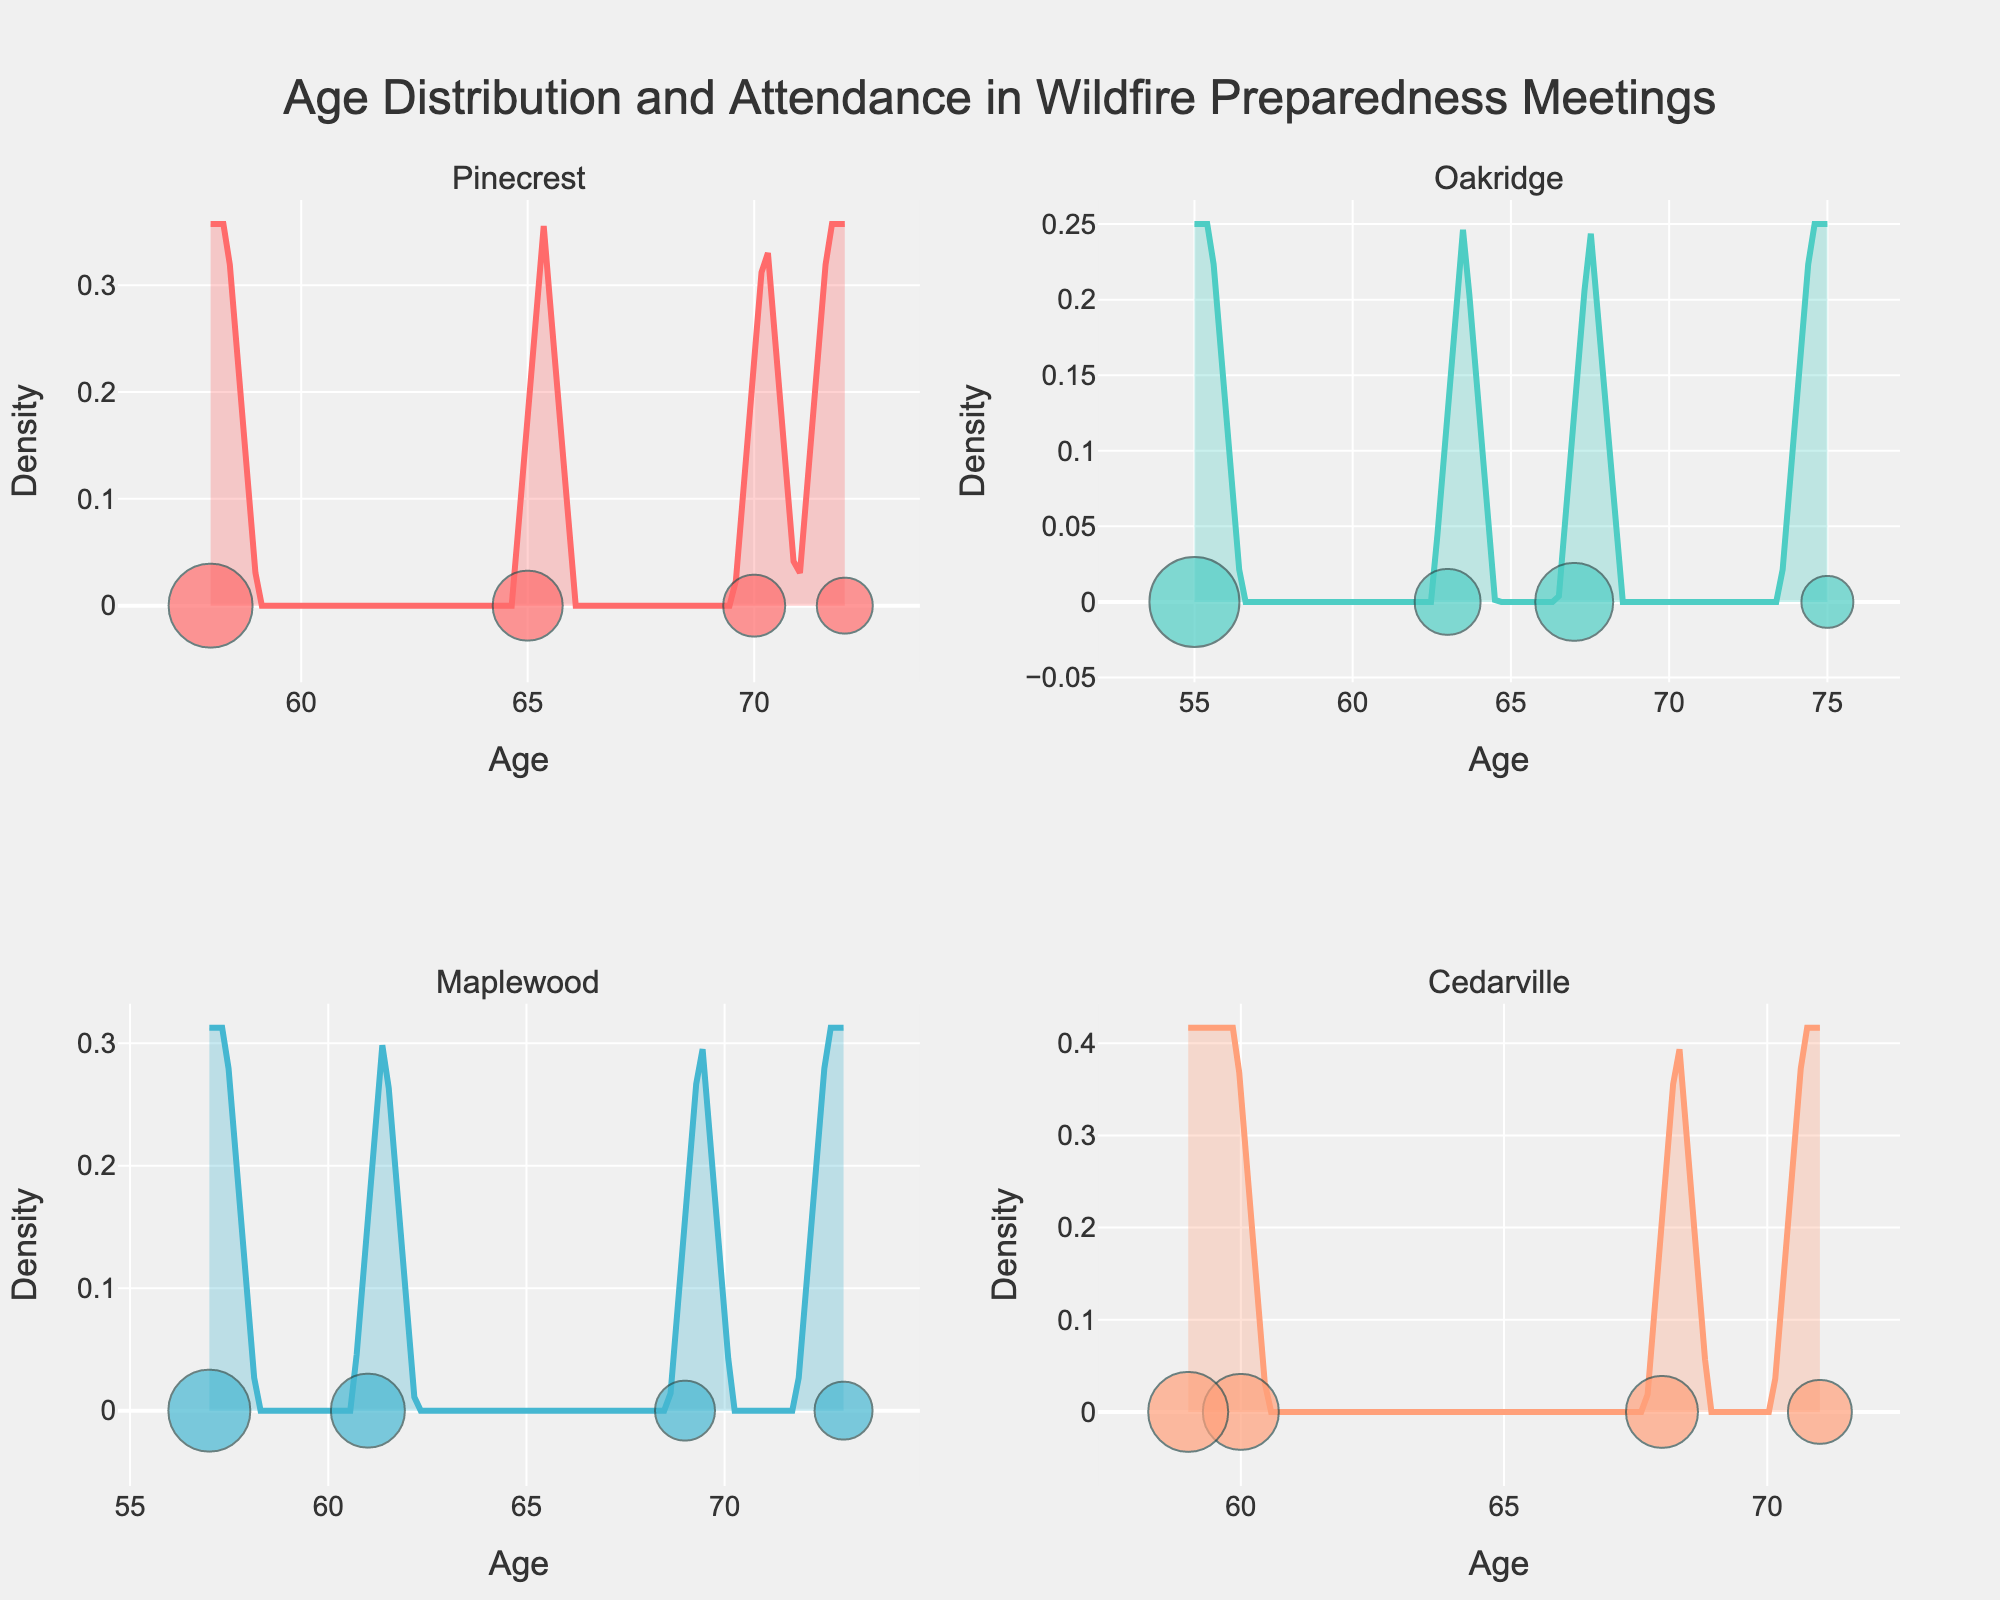Which community subplot has the highest peak density? In the figure, observe the height of peak densities in each community's subplot. The community with the tallest peak indicates the highest density.
Answer: Oakridge Which community shows the most dispersed age distribution? The community with the widest spread of the density curve indicates more dispersion. Check the subplots to see which community's density curve spans the largest range of ages.
Answer: Cedarville What is the title of the figure? The title is located at the top of the figure.
Answer: Age Distribution and Attendance in Wildfire Preparedness Meetings Are there any outliers in the Pinecrest attendance markers? Look at the Pinecrest subplot and identify any points that are significantly separate from others in terms of size or position.
Answer: No Which community has the smallest age range? Identify the span of ages in each subplot and note which has the smallest difference between the highest and lowest ages.
Answer: Cedarville Which community's subplot contains the markers with the largest attendance size? Examine all subplots and compare the relative sizes of the markers indicating attendance. The community with the largest markers will be the answer.
Answer: Oakridge Is there a community where the age density seems to have two peaks? Look for subplots with two distinct peaks in the density curve, indicating bi-modal distribution.
Answer: Maplewood Between Pinecrest and Maplewood, which has a higher average attendance? For Pinecrest and Maplewood, observe the sizes of the markers and infer which community has more consistently larger markers.
Answer: Pinecrest Which community has the narrowest peak density curve? The narrowest peak indicates a concentrated age range. Evaluate each subplot for the sharpest, highest peaks.
Answer: Pinecrest 